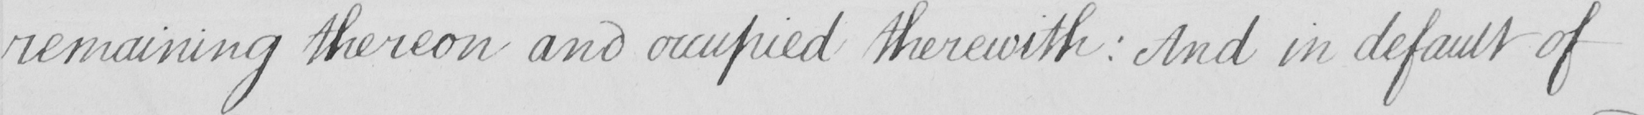Can you read and transcribe this handwriting? remaining thereon and occupied therewith :  And in default of 